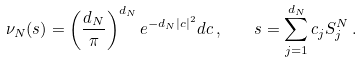<formula> <loc_0><loc_0><loc_500><loc_500>\nu _ { N } ( s ) = \left ( \frac { d _ { N } } { \pi } \right ) ^ { d _ { N } } e ^ { - d _ { N } | c | ^ { 2 } } d c \, , \quad s = \sum _ { j = 1 } ^ { d _ { N } } c _ { j } S _ { j } ^ { N } \, .</formula> 